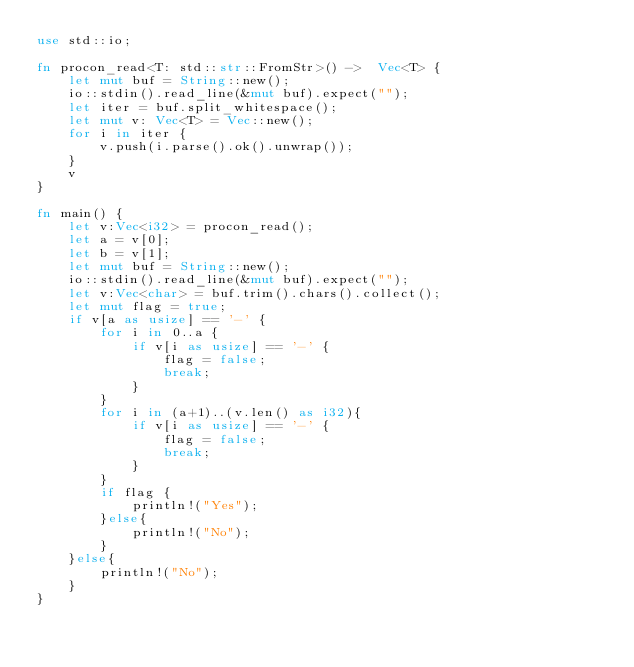<code> <loc_0><loc_0><loc_500><loc_500><_Rust_>use std::io;

fn procon_read<T: std::str::FromStr>() ->  Vec<T> {
	let mut buf = String::new();
	io::stdin().read_line(&mut buf).expect("");
	let iter = buf.split_whitespace();
	let mut v: Vec<T> = Vec::new();
	for i in iter {
		v.push(i.parse().ok().unwrap());
	}
	v
}

fn main() {
	let v:Vec<i32> = procon_read();
	let a = v[0];
	let b = v[1];
	let mut buf = String::new();
	io::stdin().read_line(&mut buf).expect("");
	let v:Vec<char> = buf.trim().chars().collect();
	let mut flag = true;
	if v[a as usize] == '-' {
		for i in 0..a {
			if v[i as usize] == '-' {
				flag = false;
				break;
			}
		}
		for i in (a+1)..(v.len() as i32){
			if v[i as usize] == '-' {
				flag = false;
				break;
			}
		}
		if flag {
			println!("Yes");
		}else{
			println!("No");
		}
	}else{
		println!("No");
	}
}</code> 